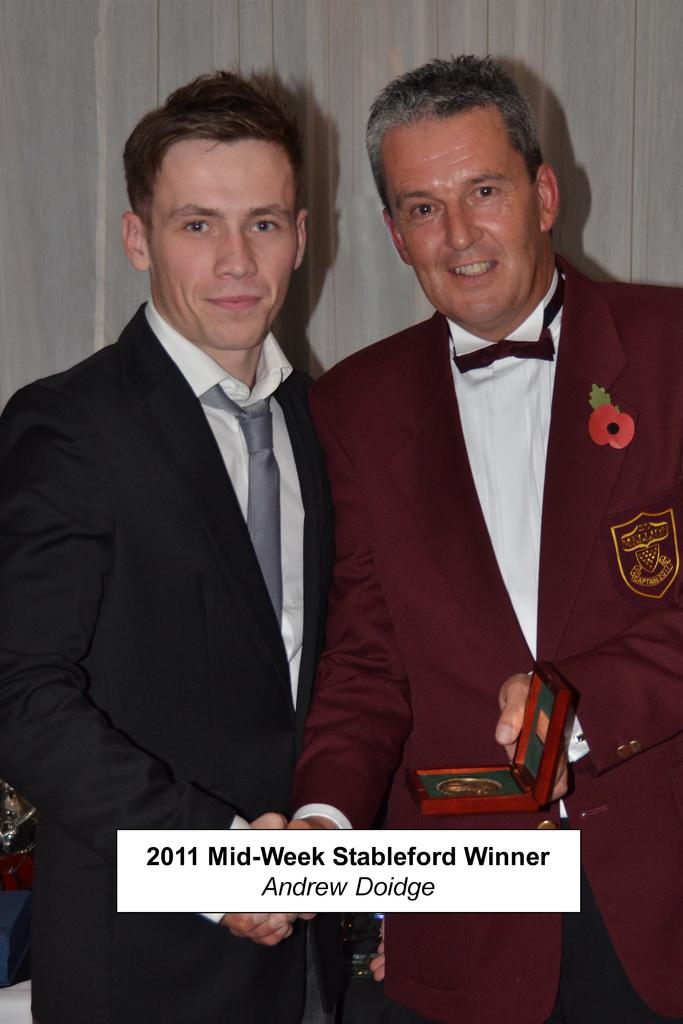How many people are present in the image? There are two people in the image. What is one person doing in the image? One person is holding an object. Can you describe the object being held? The object has text on it. What can be seen in the background of the image? There is a wall in the background of the image. What type of hammer is the man using in the image? There is no hammer present in the image. How does the man attract the attention of the other person in the image? The image does not show any specific actions to attract attention, as it only depicts two people and an object with text. 